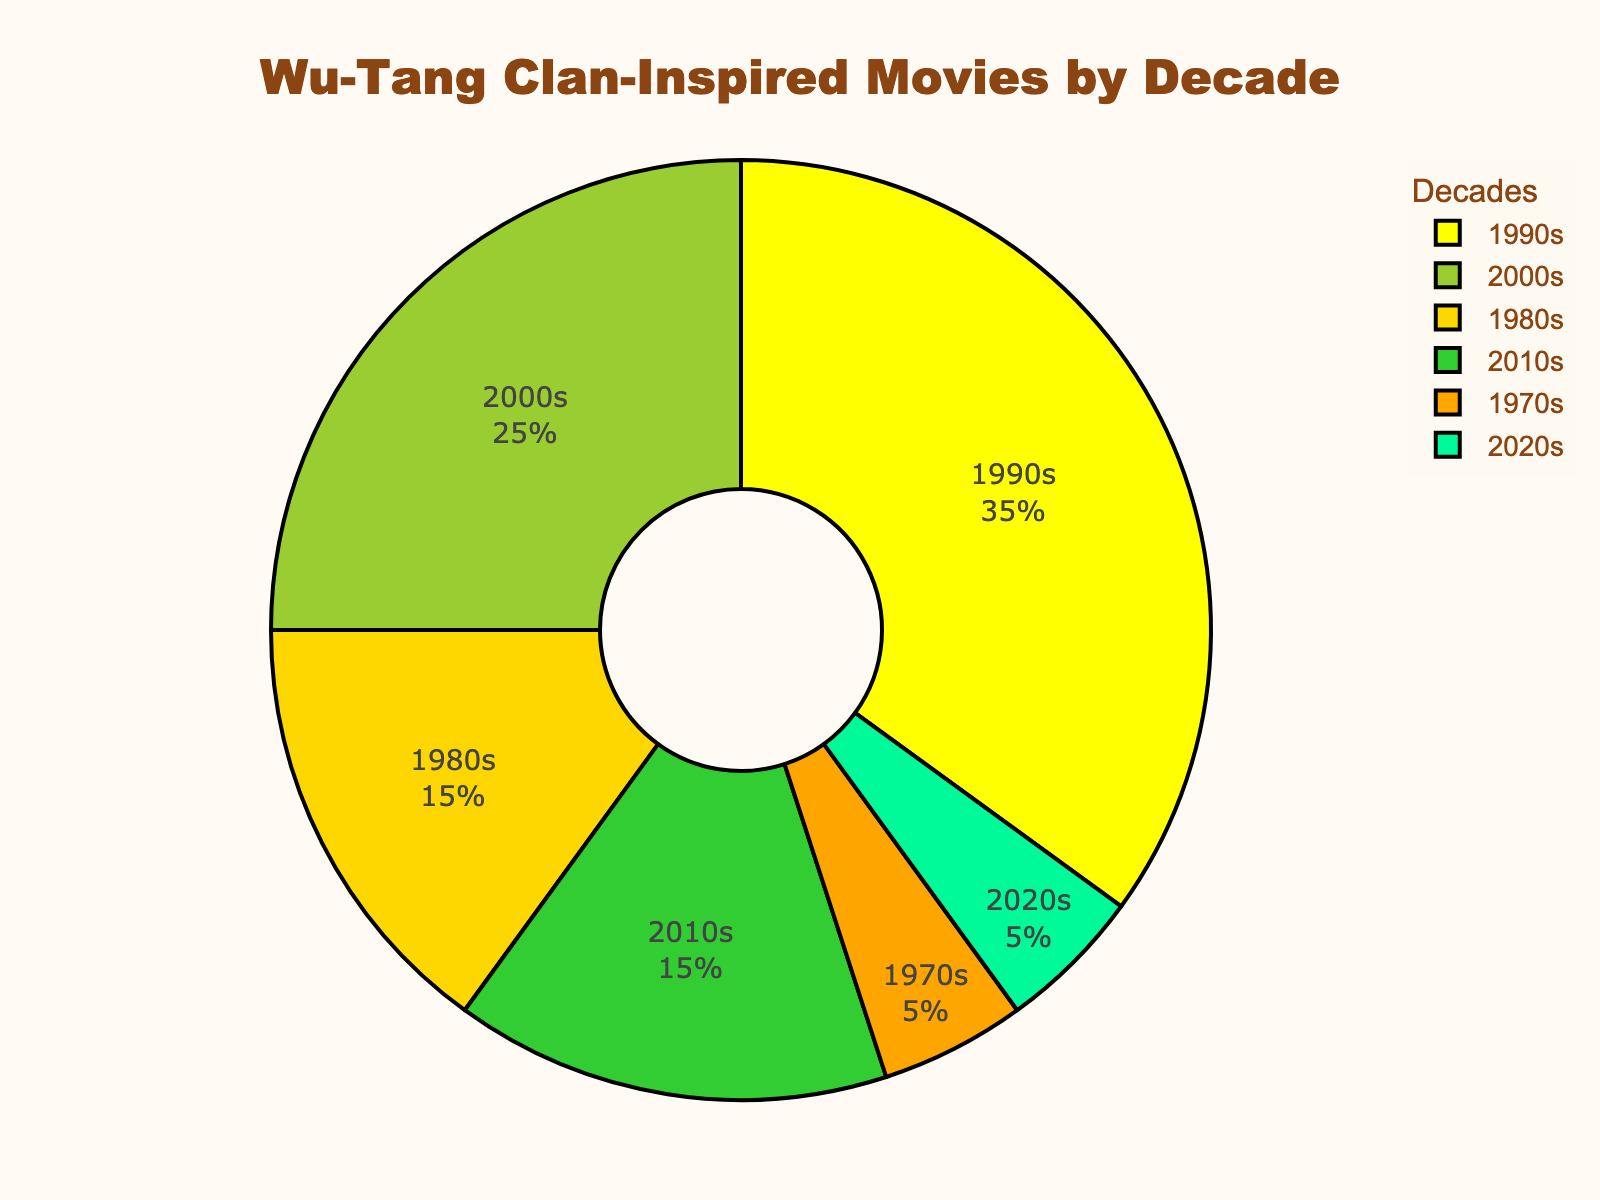Which decade has the highest percentage of Wu-Tang Clan-inspired movies? The decade with the largest section of the pie chart represents the highest percentage. The 1990s cover the largest portion of the chart.
Answer: 1990s Which two decades have the same percentage of Wu-Tang Clan-inspired movies? By looking at the pie chart, the sizes for the 1980s and 2010s are the same, both having the same percentage.
Answer: 1980s and 2010s What is the combined percentage of Wu-Tang Clan-inspired movies released in the 2000s and 2010s? Add the percentages for the 2000s (25%) and 2010s (15%). 25 + 15 = 40.
Answer: 40% Which decade has a lower percentage of Wu-Tang Clan-inspired movies, the 1970s or the 2020s? Compare the sections representing the 1970s and 2020s. Both have the same size, so they are equal.
Answer: Equal How many times larger is the percentage of movies from the 1990s compared to the 1970s? The percentage for the 1990s is 35%, and for the 1970s, it is 5%. So, 35 ÷ 5 = 7.
Answer: 7 times larger What is the difference in the percentage of Wu-Tang Clan-inspired movies between the 1980s and 2000s? Subtract the smaller percentage (1980s: 15%) from the larger percentage (2000s: 25%). 25 - 15 = 10.
Answer: 10% Which color represents the decade with the smallest percentage of Wu-Tang Clan-inspired movies? Identify the smallest sections (1970s and 2020s, both with 5%) and their corresponding colors. The color for these sections is '#FFA500'.
Answer: Orange 